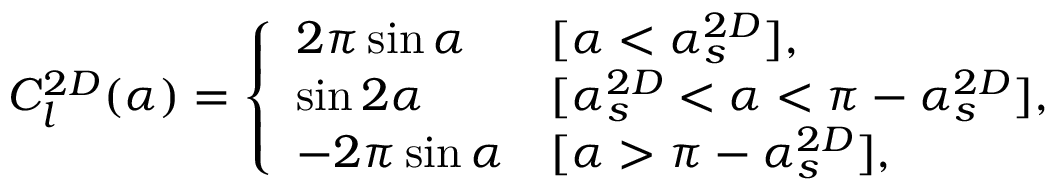<formula> <loc_0><loc_0><loc_500><loc_500>\begin{array} { r } { C _ { l } ^ { 2 D } ( \alpha ) = \left \{ \begin{array} { l l } { 2 \pi \sin \alpha } & { [ \alpha < \alpha _ { s } ^ { 2 D } ] , } \\ { \sin 2 \alpha } & { [ \alpha _ { s } ^ { 2 D } < \alpha < \pi - \alpha _ { s } ^ { 2 D } ] , } \\ { - 2 \pi \sin \alpha } & { [ \alpha > \pi - \alpha _ { s } ^ { 2 D } ] , } \end{array} } \end{array}</formula> 